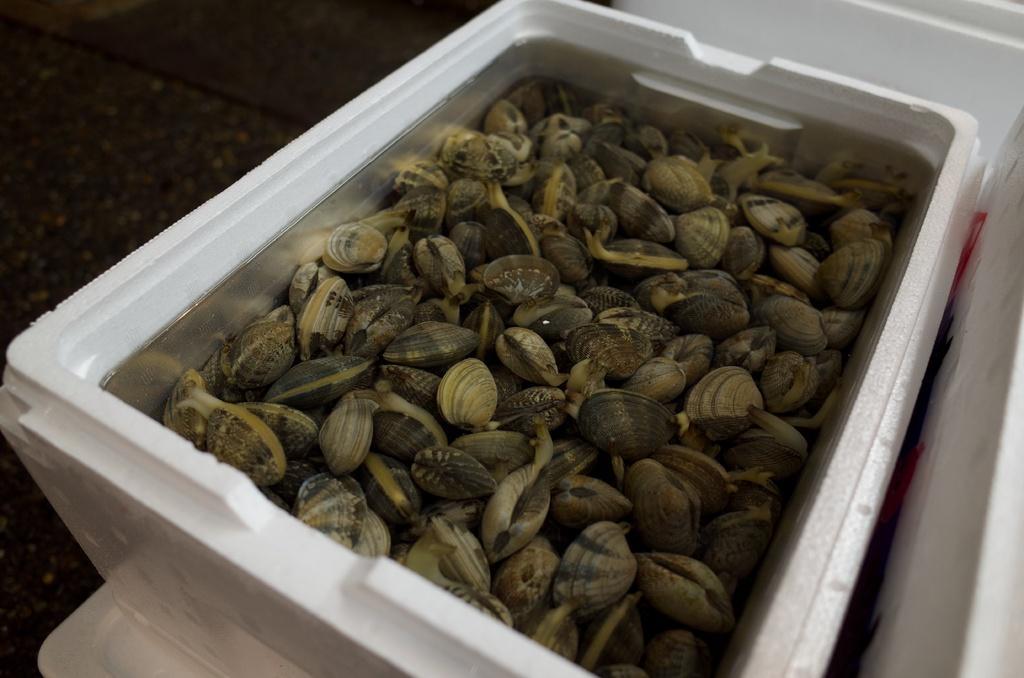Describe this image in one or two sentences. In this picture, we see a white box or a bowl containing the cockles. In the left top, it is black in color. In the background, it is white in color. On the right side, we see an object in white color. 